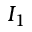<formula> <loc_0><loc_0><loc_500><loc_500>I _ { 1 }</formula> 